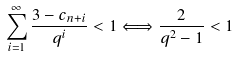Convert formula to latex. <formula><loc_0><loc_0><loc_500><loc_500>\sum _ { i = 1 } ^ { \infty } \frac { 3 - c _ { n + i } } { q ^ { i } } < 1 \Longleftrightarrow \frac { 2 } { q ^ { 2 } - 1 } < 1</formula> 